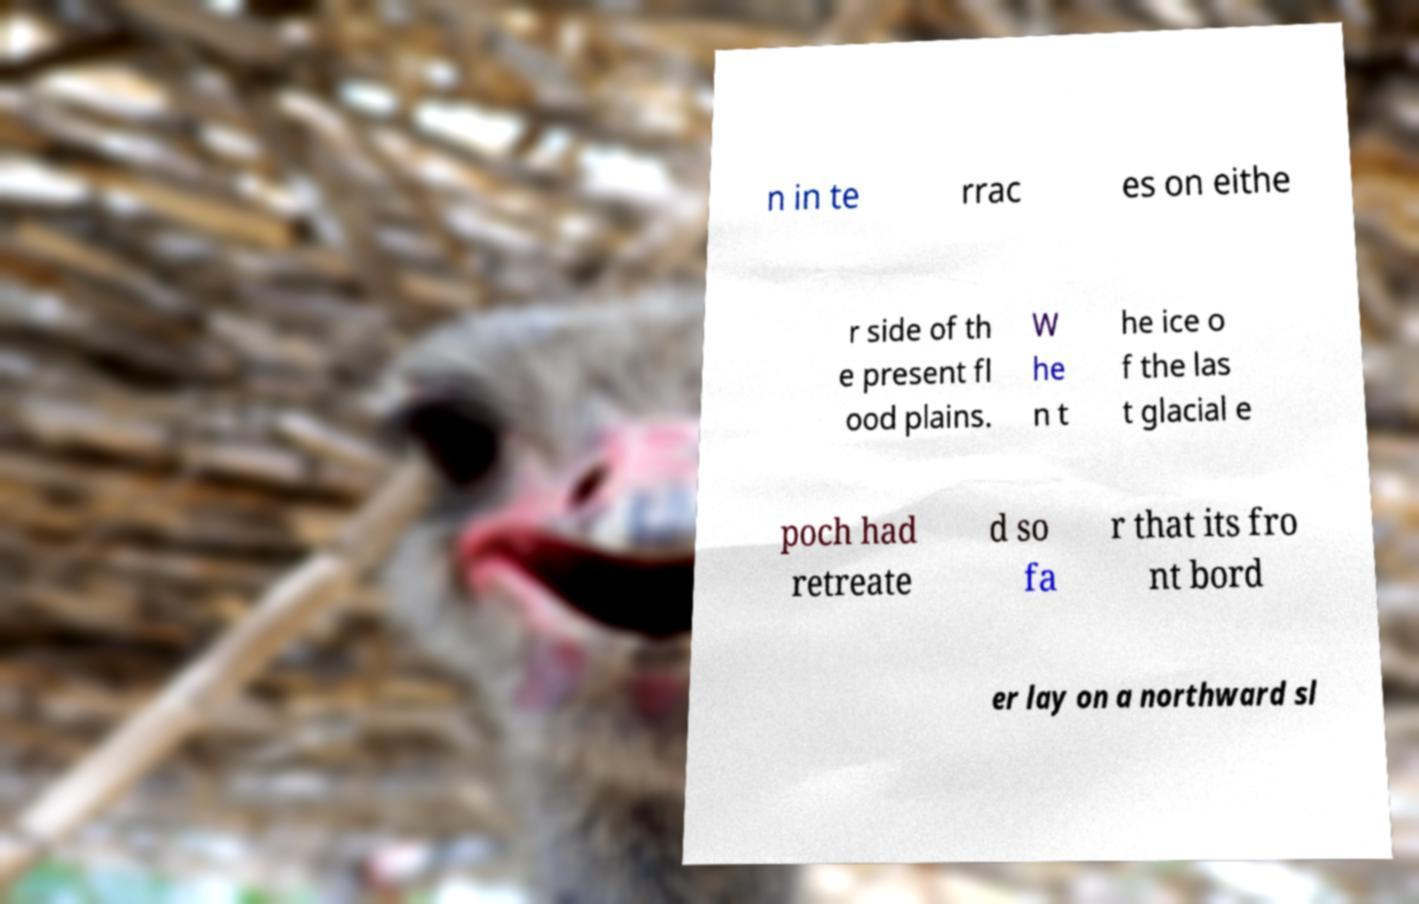Please identify and transcribe the text found in this image. n in te rrac es on eithe r side of th e present fl ood plains. W he n t he ice o f the las t glacial e poch had retreate d so fa r that its fro nt bord er lay on a northward sl 